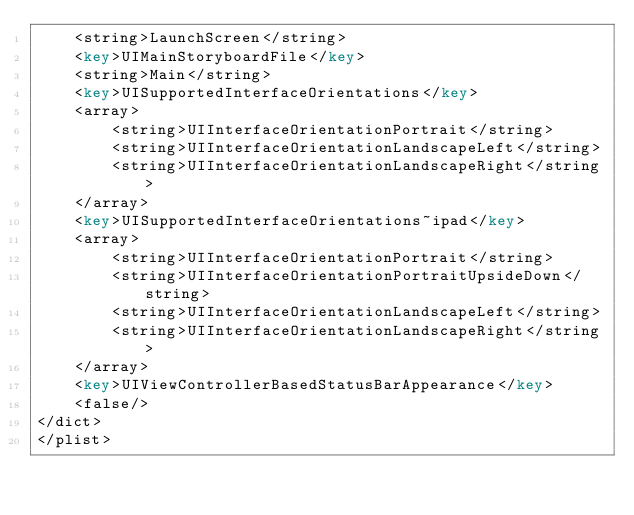Convert code to text. <code><loc_0><loc_0><loc_500><loc_500><_XML_>	<string>LaunchScreen</string>
	<key>UIMainStoryboardFile</key>
	<string>Main</string>
	<key>UISupportedInterfaceOrientations</key>
	<array>
		<string>UIInterfaceOrientationPortrait</string>
		<string>UIInterfaceOrientationLandscapeLeft</string>
		<string>UIInterfaceOrientationLandscapeRight</string>
	</array>
	<key>UISupportedInterfaceOrientations~ipad</key>
	<array>
		<string>UIInterfaceOrientationPortrait</string>
		<string>UIInterfaceOrientationPortraitUpsideDown</string>
		<string>UIInterfaceOrientationLandscapeLeft</string>
		<string>UIInterfaceOrientationLandscapeRight</string>
	</array>
	<key>UIViewControllerBasedStatusBarAppearance</key>
	<false/>
</dict>
</plist>
</code> 